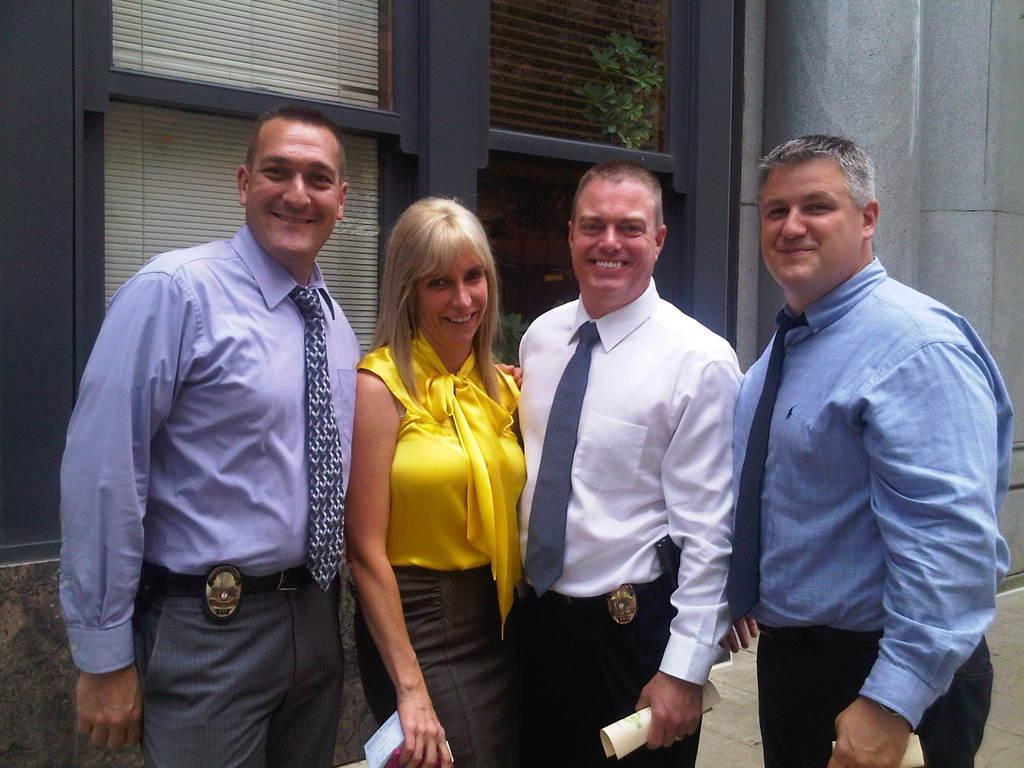Please provide a concise description of this image. Here we can see three men and a woman standing and among them three persons are holding papers in their hands. In the background we can see all,windows,house plant and pillars. 